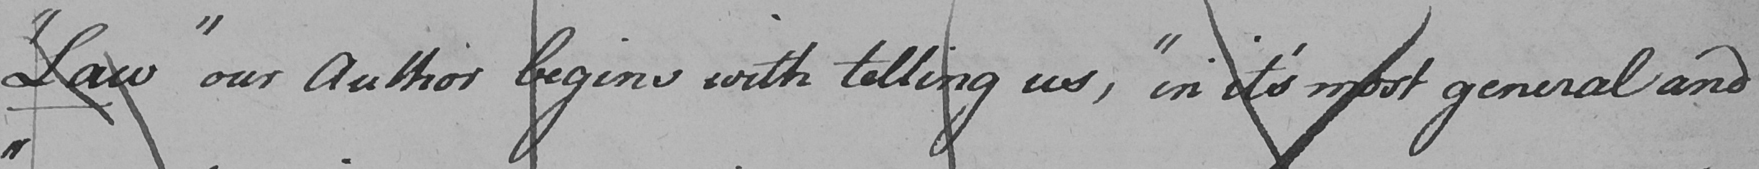What text is written in this handwritten line? " Law "  our Author begins with telling us ,  " in it ' s most general and 